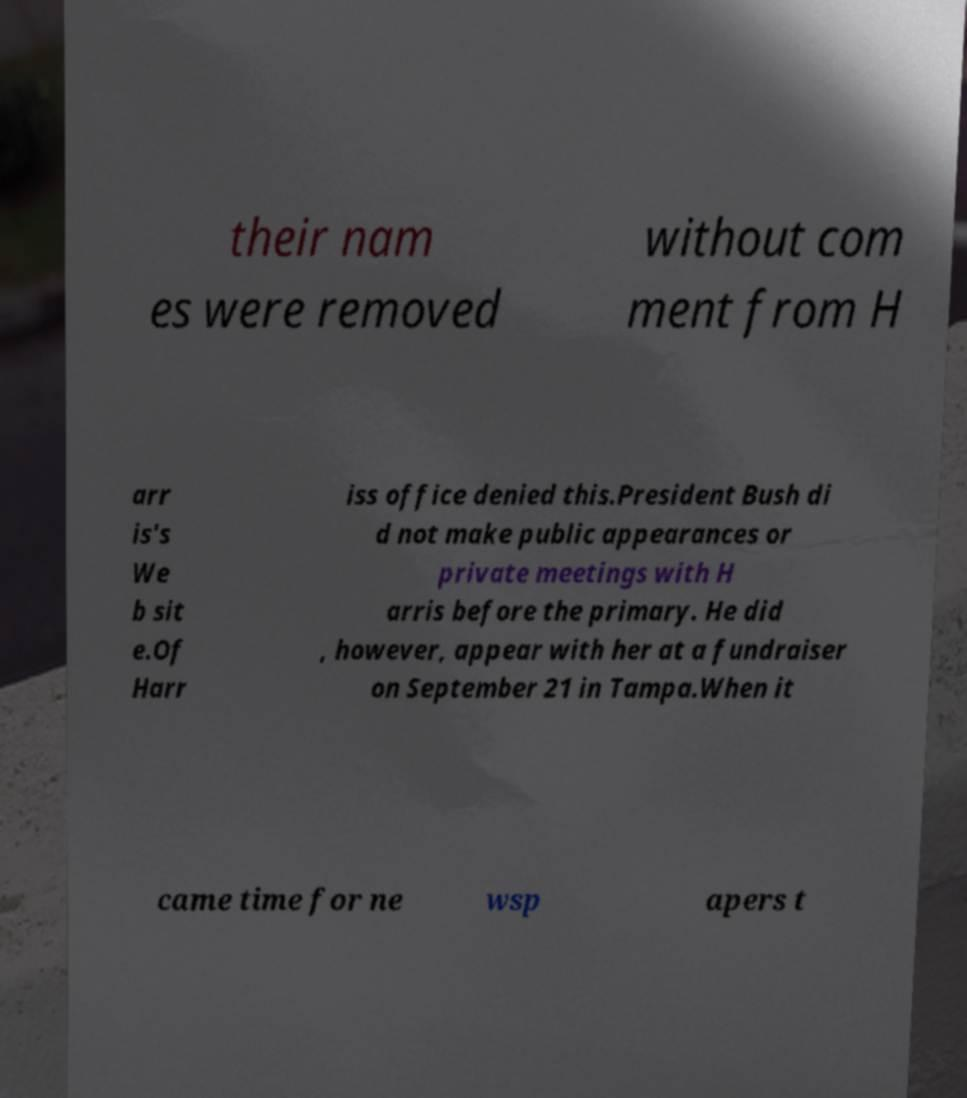Can you accurately transcribe the text from the provided image for me? their nam es were removed without com ment from H arr is's We b sit e.Of Harr iss office denied this.President Bush di d not make public appearances or private meetings with H arris before the primary. He did , however, appear with her at a fundraiser on September 21 in Tampa.When it came time for ne wsp apers t 